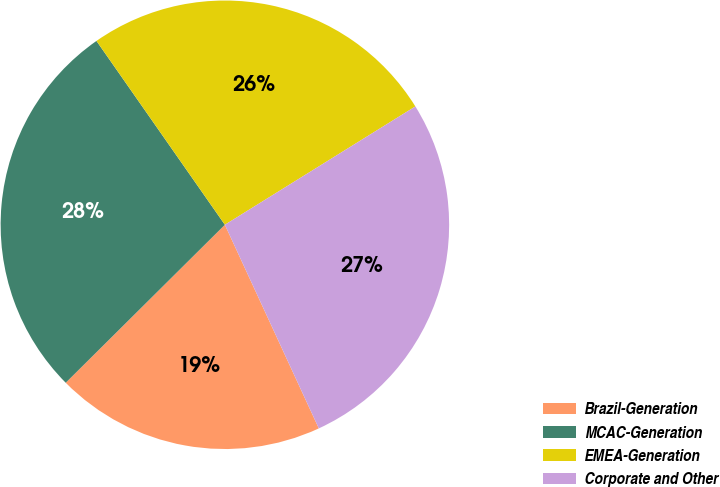Convert chart to OTSL. <chart><loc_0><loc_0><loc_500><loc_500><pie_chart><fcel>Brazil-Generation<fcel>MCAC-Generation<fcel>EMEA-Generation<fcel>Corporate and Other<nl><fcel>19.44%<fcel>27.74%<fcel>25.86%<fcel>26.97%<nl></chart> 